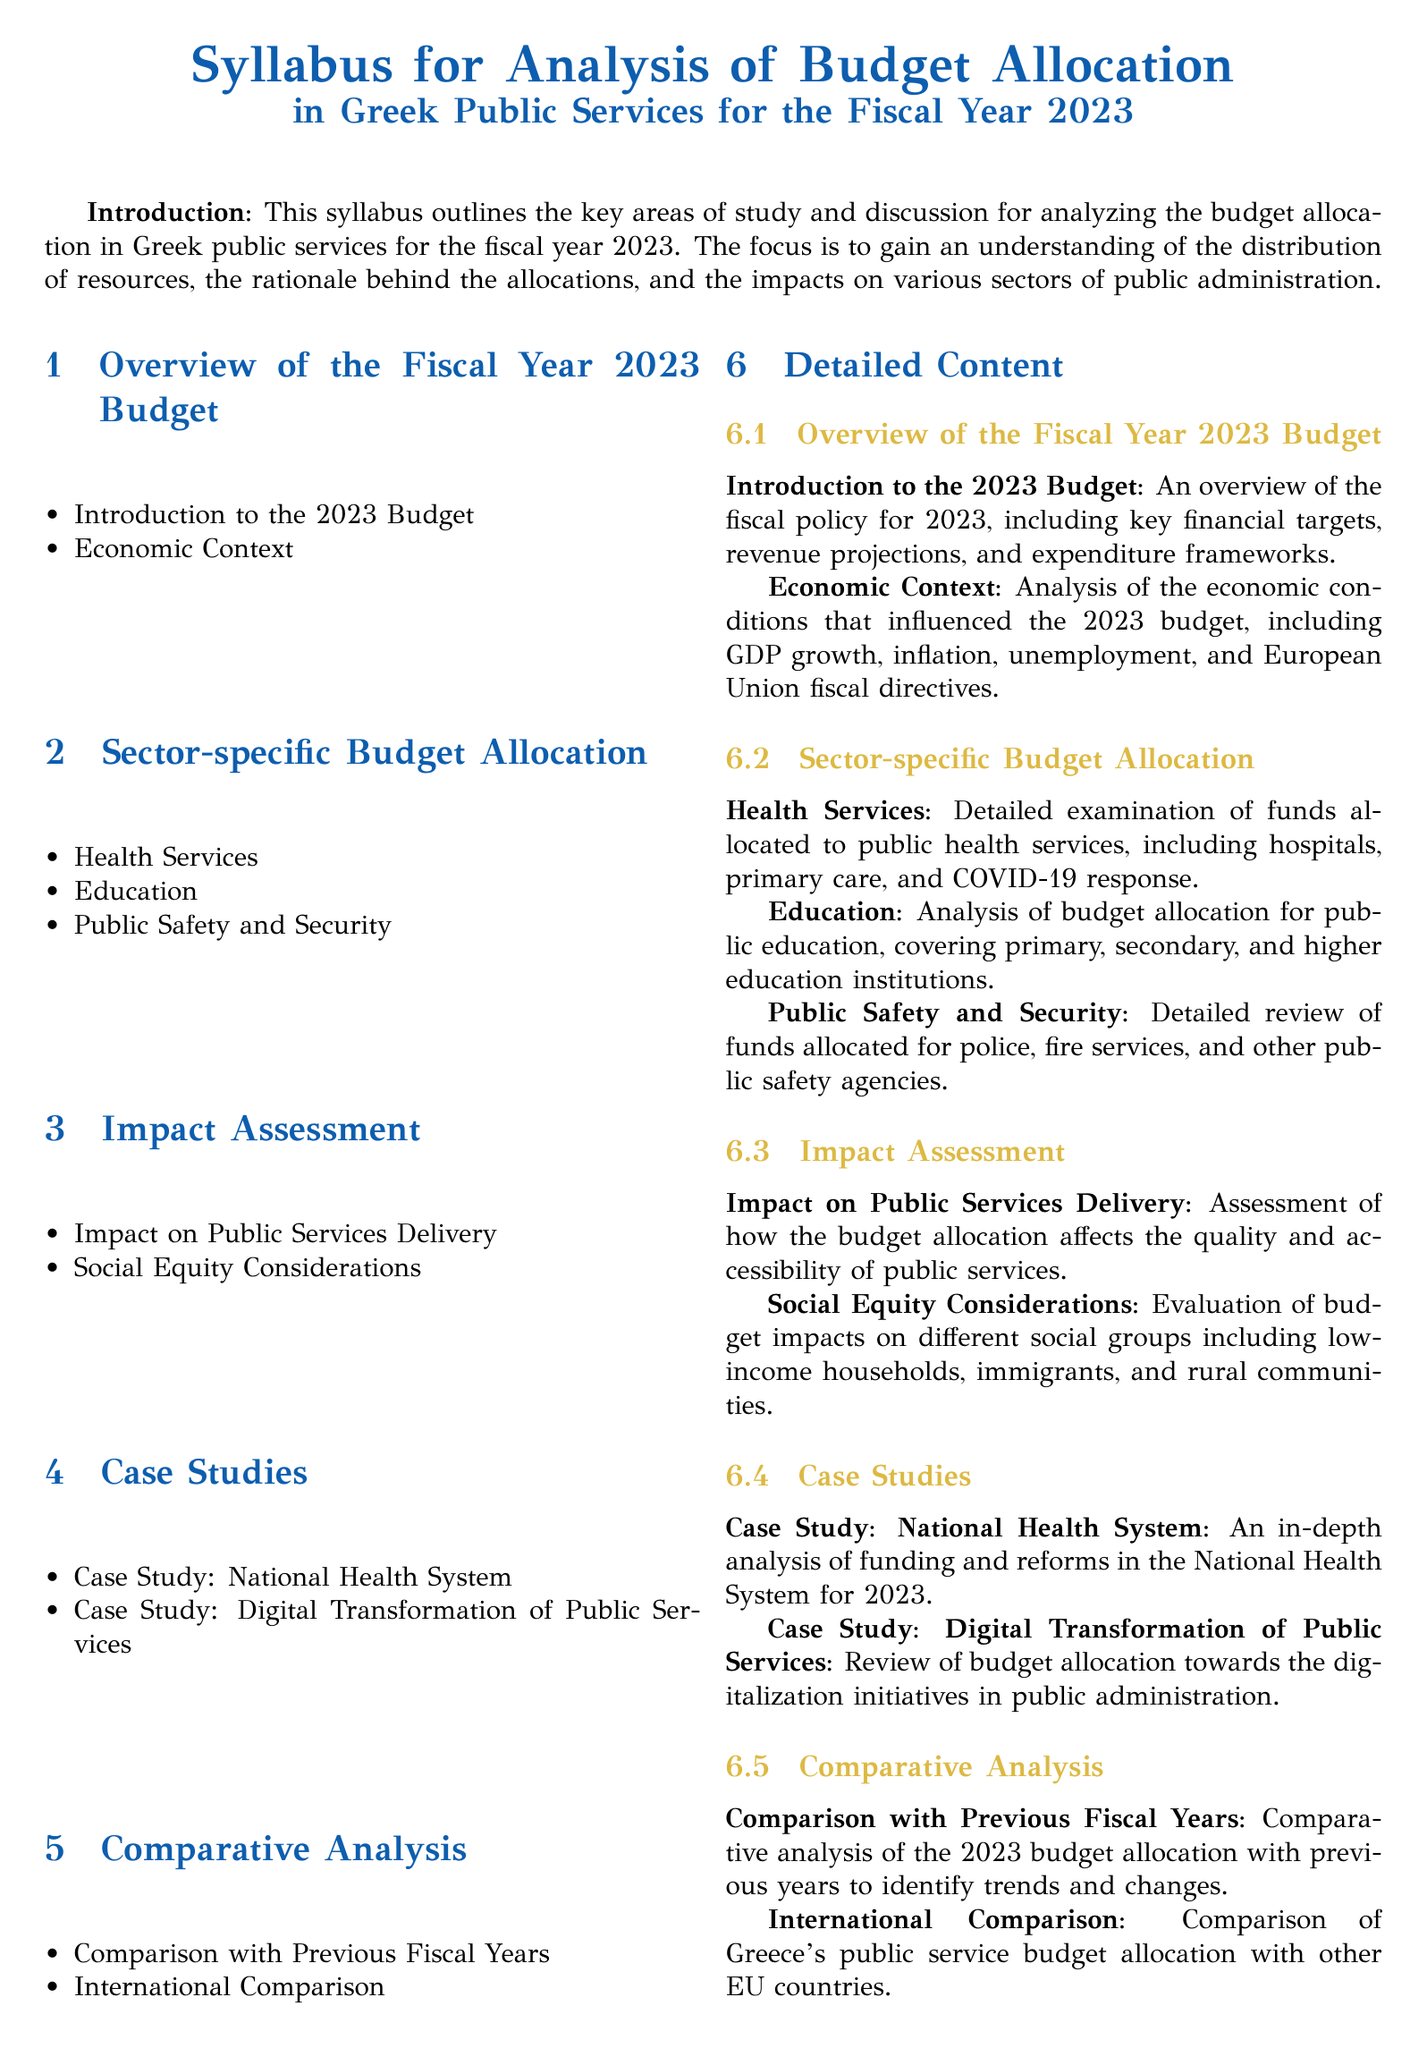What is the focus of the syllabus? The focus is to gain an understanding of the distribution of resources, the rationale behind the allocations, and the impacts on various sectors of public administration.
Answer: Distribution of resources What is one of the sectors addressed in the budget allocation? The document lists several sectors, one of which is Health Services.
Answer: Health Services Which system receives a case study examination? The document specifies that the National Health System is one of the case studies included.
Answer: National Health System What is analyzed under the impact assessment section? The impact on Public Services Delivery is one of the topics analyzed in this section.
Answer: Public Services Delivery How does the syllabus suggest the 2023 budget compares to previous years? It states that there will be a comparison with Previous Fiscal Years to identify trends and changes.
Answer: Previous Fiscal Years What is one consideration evaluated regarding budget impacts? The document indicates that Social Equity Considerations are a key evaluation point.
Answer: Social Equity Considerations What is the concluding section of the syllabus focused on? The conclusion provides a summary of key findings and recommendations for policymakers and stakeholders.
Answer: Summary of key findings What is the title of the syllabus? The title outlines the subject of investigation and states it is about the Analysis of Budget Allocation in Greek Public Services.
Answer: Analysis of Budget Allocation in Greek Public Services for the Fiscal Year 2023 